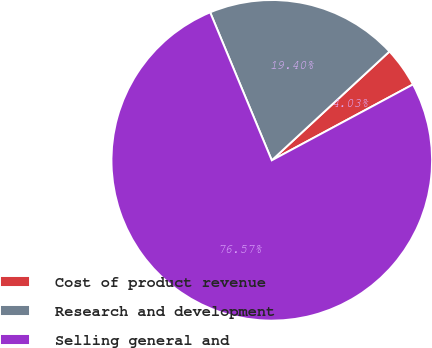Convert chart. <chart><loc_0><loc_0><loc_500><loc_500><pie_chart><fcel>Cost of product revenue<fcel>Research and development<fcel>Selling general and<nl><fcel>4.03%<fcel>19.4%<fcel>76.57%<nl></chart> 